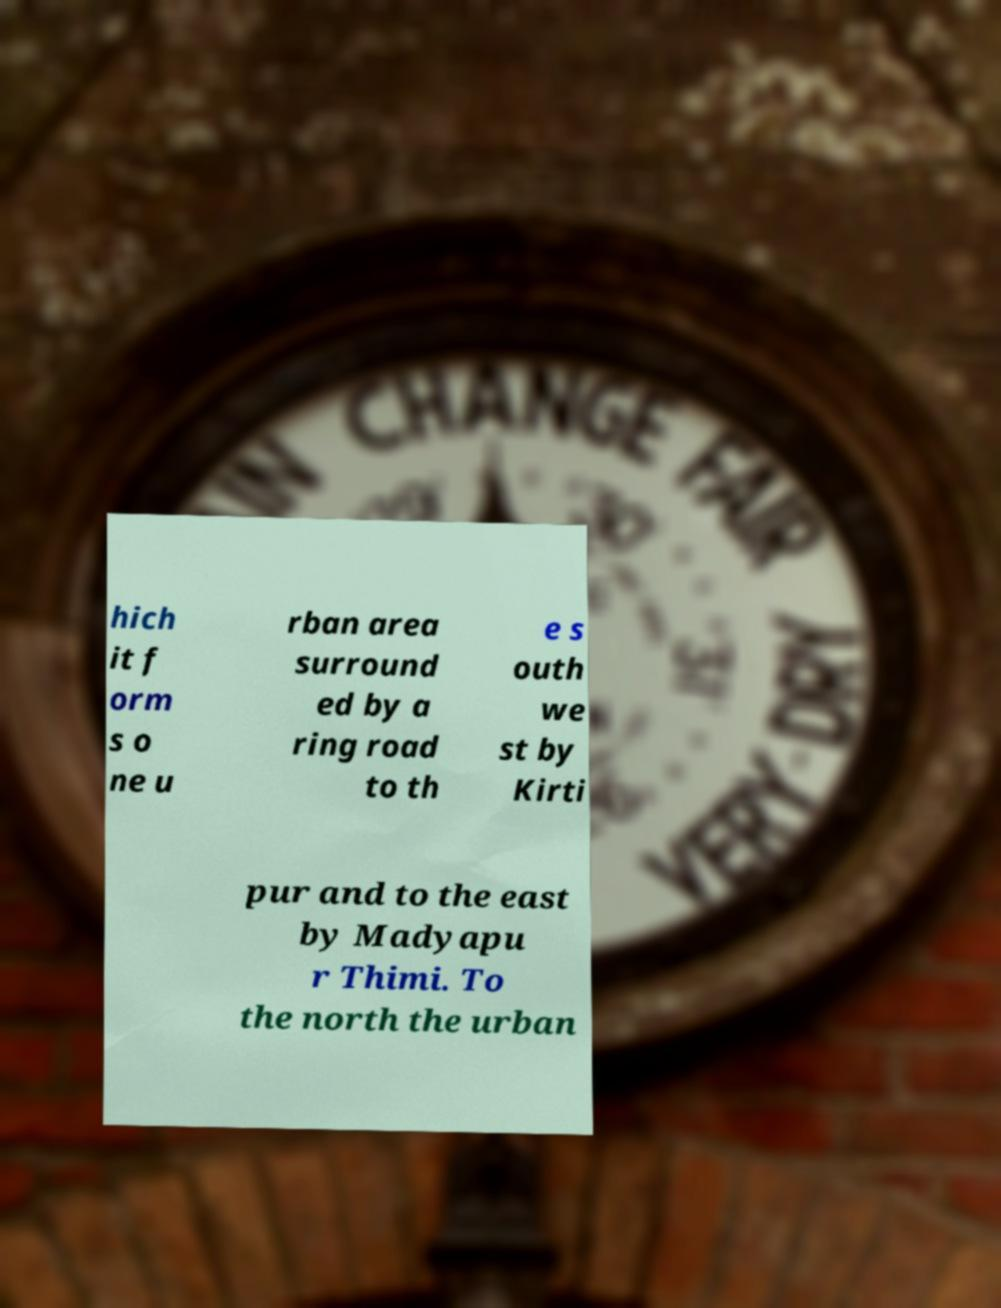What messages or text are displayed in this image? I need them in a readable, typed format. hich it f orm s o ne u rban area surround ed by a ring road to th e s outh we st by Kirti pur and to the east by Madyapu r Thimi. To the north the urban 